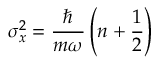Convert formula to latex. <formula><loc_0><loc_0><loc_500><loc_500>\sigma _ { x } ^ { 2 } = { \frac { } { m \omega } } \left ( n + { \frac { 1 } { 2 } } \right )</formula> 